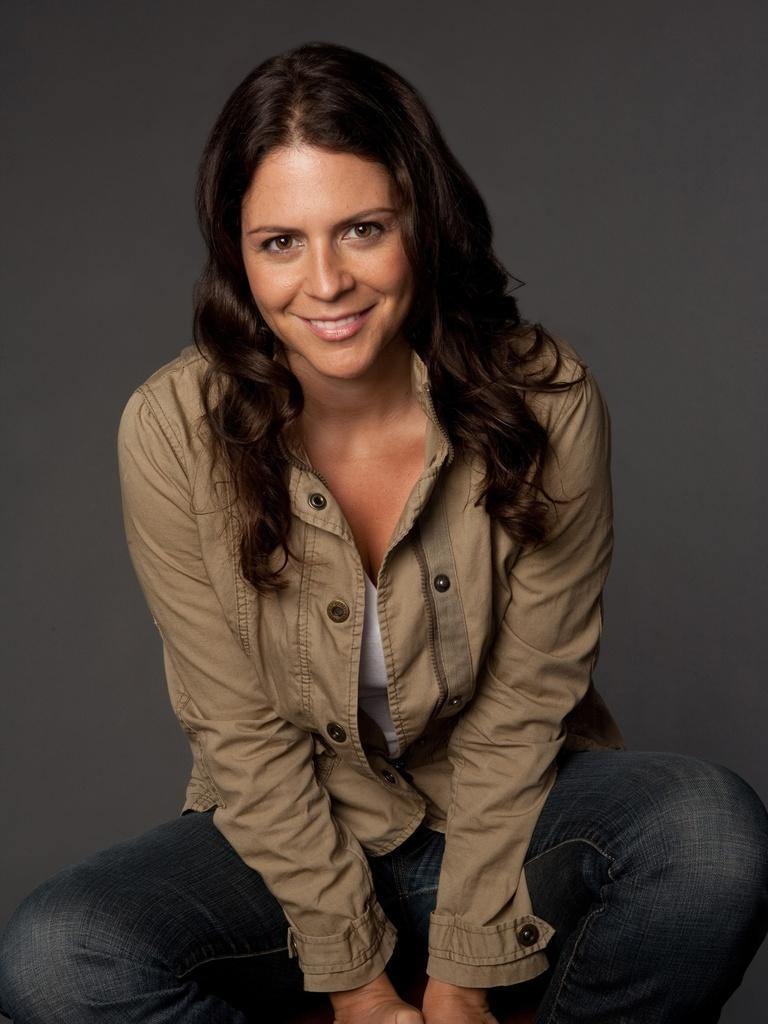How would you summarize this image in a sentence or two? In this image we can see a woman. 